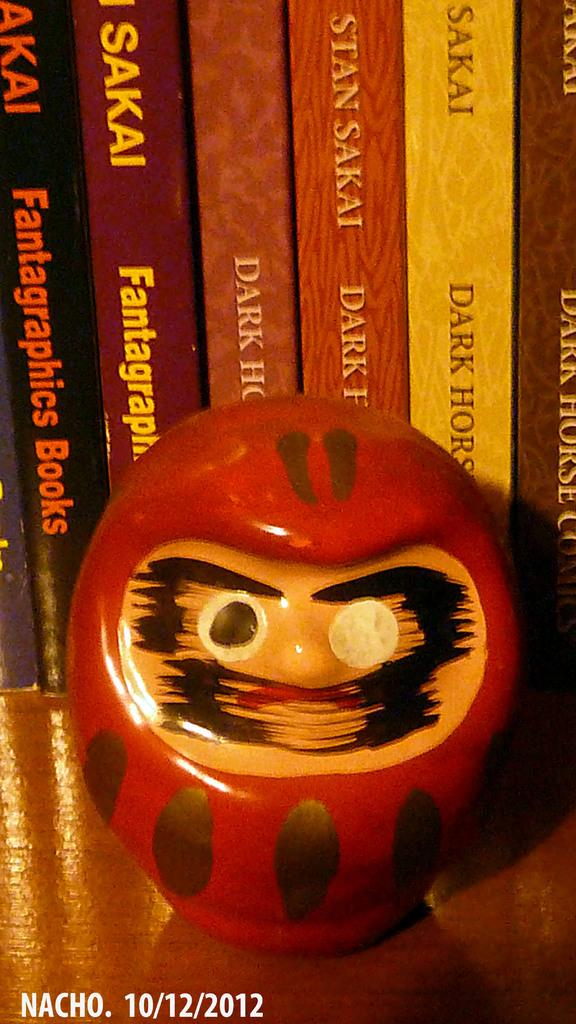<image>
Relay a brief, clear account of the picture shown. Various books by Sakai are lined up behind a painted toy. 